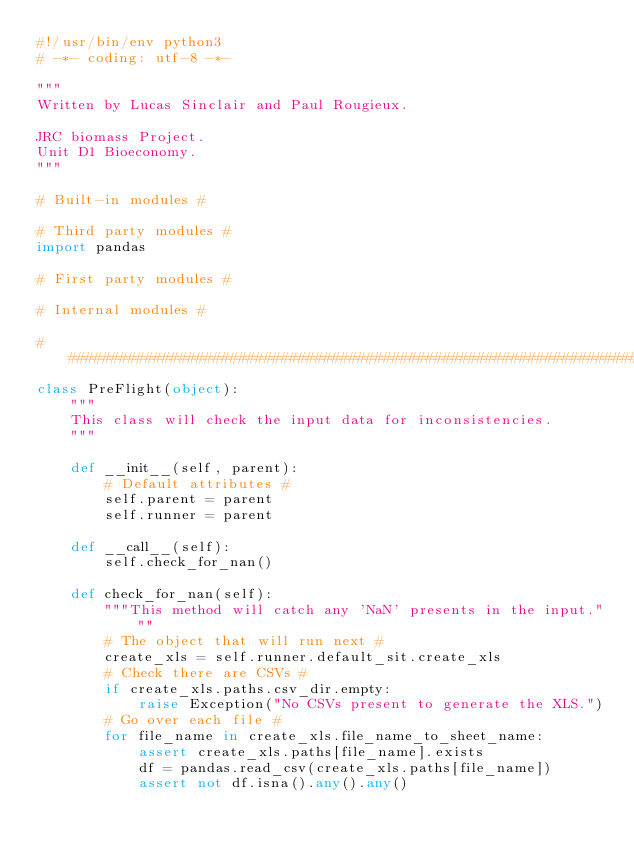<code> <loc_0><loc_0><loc_500><loc_500><_Python_>#!/usr/bin/env python3
# -*- coding: utf-8 -*-

"""
Written by Lucas Sinclair and Paul Rougieux.

JRC biomass Project.
Unit D1 Bioeconomy.
"""

# Built-in modules #

# Third party modules #
import pandas

# First party modules #

# Internal modules #

###############################################################################
class PreFlight(object):
    """
    This class will check the input data for inconsistencies.
    """

    def __init__(self, parent):
        # Default attributes #
        self.parent = parent
        self.runner = parent

    def __call__(self):
        self.check_for_nan()

    def check_for_nan(self):
        """This method will catch any 'NaN' presents in the input."""
        # The object that will run next #
        create_xls = self.runner.default_sit.create_xls
        # Check there are CSVs #
        if create_xls.paths.csv_dir.empty:
            raise Exception("No CSVs present to generate the XLS.")
        # Go over each file #
        for file_name in create_xls.file_name_to_sheet_name:
            assert create_xls.paths[file_name].exists
            df = pandas.read_csv(create_xls.paths[file_name])
            assert not df.isna().any().any()</code> 